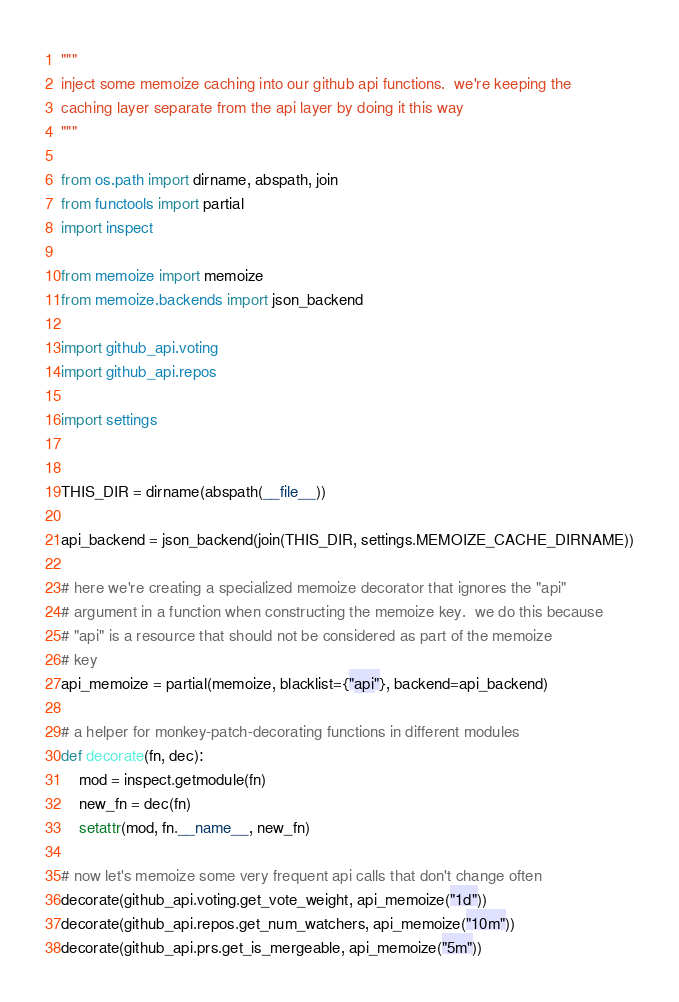Convert code to text. <code><loc_0><loc_0><loc_500><loc_500><_Python_>"""
inject some memoize caching into our github api functions.  we're keeping the
caching layer separate from the api layer by doing it this way
"""

from os.path import dirname, abspath, join
from functools import partial
import inspect

from memoize import memoize
from memoize.backends import json_backend

import github_api.voting
import github_api.repos

import settings


THIS_DIR = dirname(abspath(__file__))

api_backend = json_backend(join(THIS_DIR, settings.MEMOIZE_CACHE_DIRNAME))

# here we're creating a specialized memoize decorator that ignores the "api"
# argument in a function when constructing the memoize key.  we do this because
# "api" is a resource that should not be considered as part of the memoize
# key
api_memoize = partial(memoize, blacklist={"api"}, backend=api_backend)

# a helper for monkey-patch-decorating functions in different modules
def decorate(fn, dec):
    mod = inspect.getmodule(fn)
    new_fn = dec(fn)
    setattr(mod, fn.__name__, new_fn)

# now let's memoize some very frequent api calls that don't change often
decorate(github_api.voting.get_vote_weight, api_memoize("1d"))
decorate(github_api.repos.get_num_watchers, api_memoize("10m"))
decorate(github_api.prs.get_is_mergeable, api_memoize("5m"))


</code> 